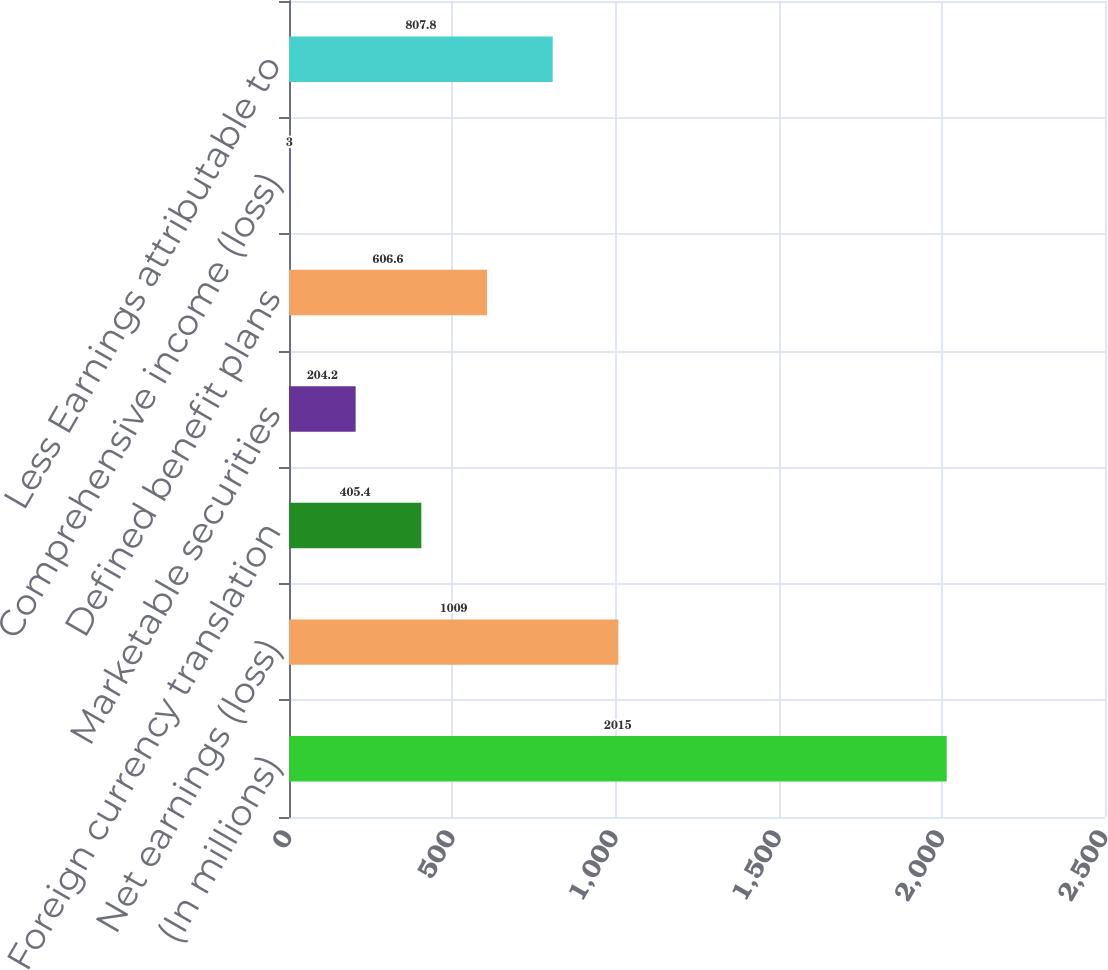Convert chart to OTSL. <chart><loc_0><loc_0><loc_500><loc_500><bar_chart><fcel>(In millions)<fcel>Net earnings (loss)<fcel>Foreign currency translation<fcel>Marketable securities<fcel>Defined benefit plans<fcel>Comprehensive income (loss)<fcel>Less Earnings attributable to<nl><fcel>2015<fcel>1009<fcel>405.4<fcel>204.2<fcel>606.6<fcel>3<fcel>807.8<nl></chart> 